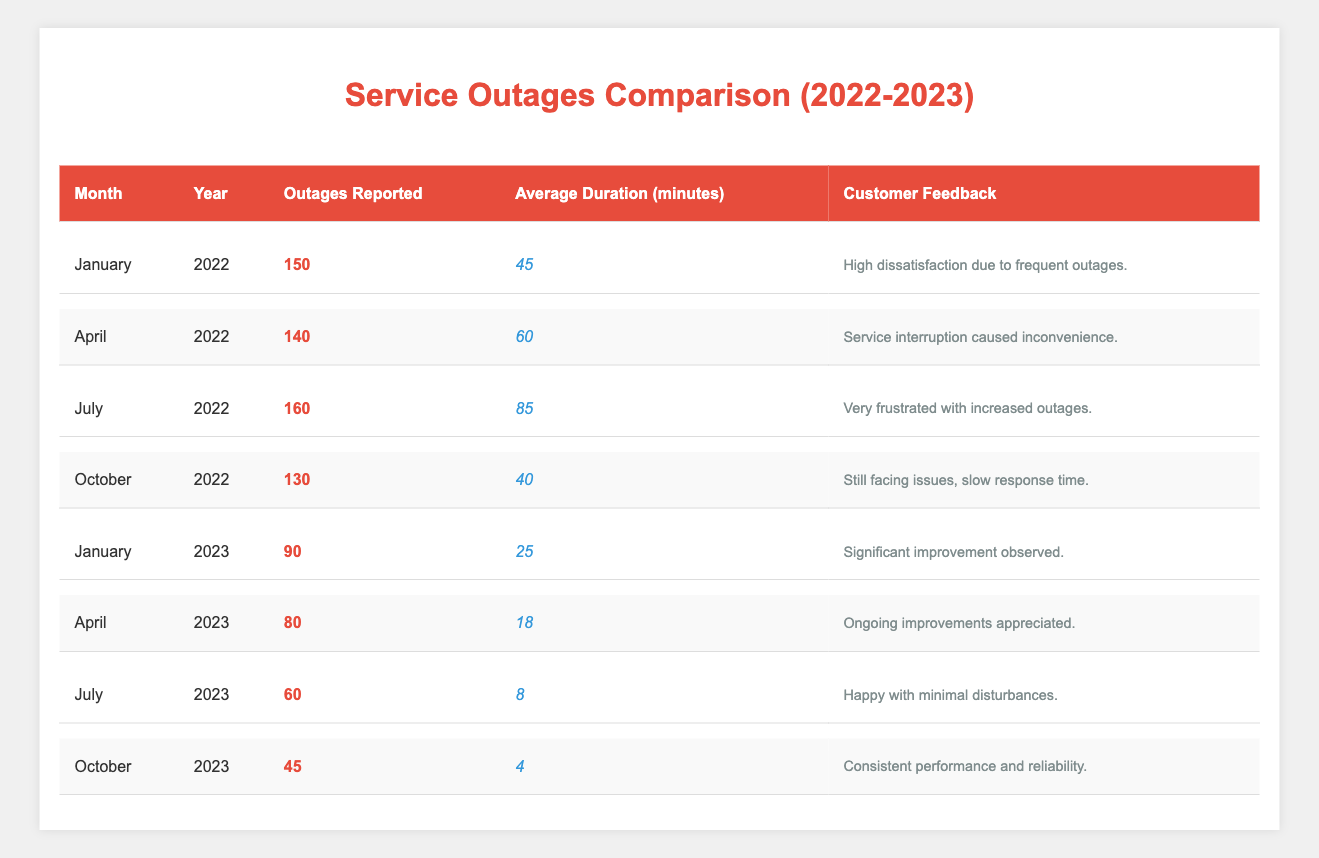What was the highest number of outages reported in 2022? In the table, the month with the highest outages reported in 2022 is August, with a total of 175 outages.
Answer: 175 What was the average duration of outages in July 2023? The table shows that the average duration for outages in July 2023 was 8 minutes.
Answer: 8 How many outages were reported in January 2022 compared to January 2023? In January 2022, there were 150 outages reported. In January 2023, this number decreased to 90. The difference is 150 - 90 = 60.
Answer: 60 Did the customer feedback improve from December 2022 to January 2023? The customer feedback for December 2022 noted feeling hopeful about service recovery, while January 2023 reported significant improvement observed. This indicates an improvement in customer sentiment.
Answer: Yes What was the total number of outages reported from January to October 2023? Adding the outages from January (90), February (85), March (75), April (80), May (70), June (65), July (60), August (55), September (50), and October (45) gives a total of 90 + 85 + 75 + 80 + 70 + 65 + 60 + 55 + 50 + 45 = 855.
Answer: 855 What percentage decrease in outages was observed from July 2022 to July 2023? In July 2022, there were 160 outages reported, and in July 2023, there were 60. The decrease is 160 - 60 = 100. The percentage decrease is (100/160) * 100% = 62.5%.
Answer: 62.5% In what month did the customer feedback describe the service as "excellent"? The feedback describes the service as excellent in March 2023, coinciding with the lowest number of outages reported up to that point.
Answer: March 2023 Was there a trend of any kind in customer feedback throughout 2023? Yes, customer feedback throughout 2023 showed a clear trend of increasing satisfaction, moving from significant improvement in January to feeling secure with electrical services by October.
Answer: Yes What was the lowest average outage duration recorded in 2023? The lowest average duration of outages was recorded in October 2023, with an average of 4 minutes.
Answer: 4 What was the month with the highest reported outages in 2023? The month with the highest reported outages in 2023 was January, with 90 outages reported.
Answer: January 2023 How many more outages were reported in May 2022 than in May 2023? May 2022 had 125 outages, while May 2023 recorded 70 outages. Thus, 125 - 70 = 55 more outages were reported in May 2022 compared to May 2023.
Answer: 55 